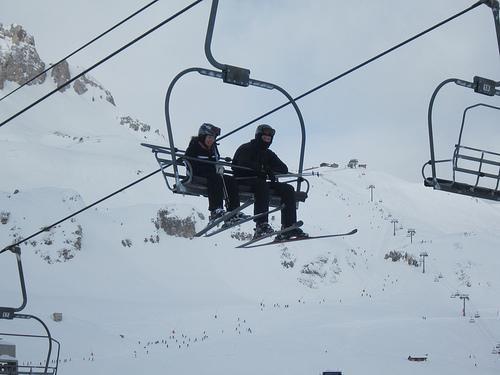How many people are there?
Give a very brief answer. 2. 